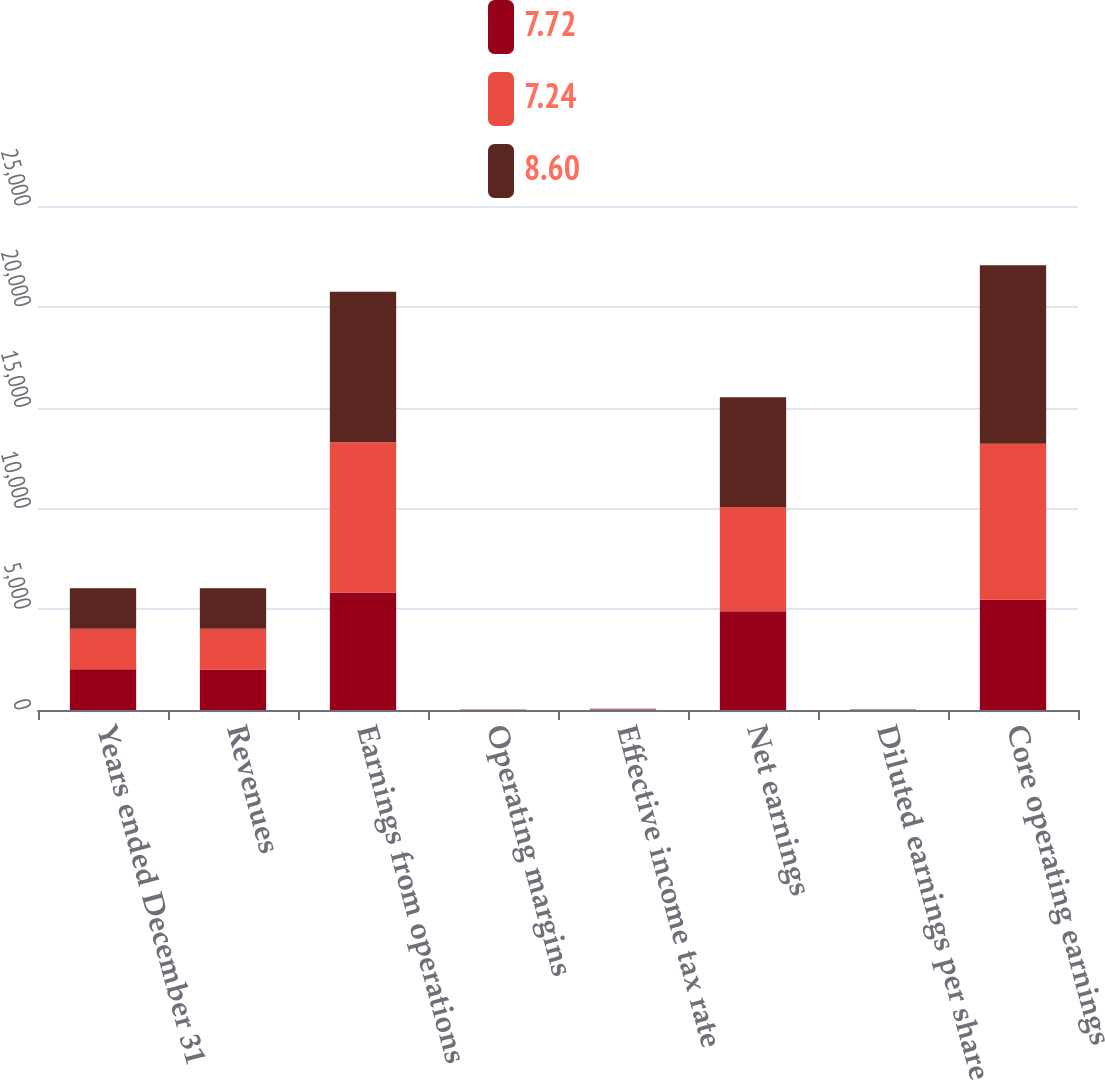Convert chart. <chart><loc_0><loc_0><loc_500><loc_500><stacked_bar_chart><ecel><fcel>Years ended December 31<fcel>Revenues<fcel>Earnings from operations<fcel>Operating margins<fcel>Effective income tax rate<fcel>Net earnings<fcel>Diluted earnings per share<fcel>Core operating earnings<nl><fcel>7.72<fcel>2016<fcel>2015<fcel>5834<fcel>6.2<fcel>12.1<fcel>4895<fcel>7.61<fcel>5464<nl><fcel>7.24<fcel>2015<fcel>2015<fcel>7443<fcel>7.7<fcel>27.7<fcel>5176<fcel>7.44<fcel>7741<nl><fcel>8.6<fcel>2014<fcel>2015<fcel>7473<fcel>8.2<fcel>23.7<fcel>5446<fcel>7.38<fcel>8860<nl></chart> 